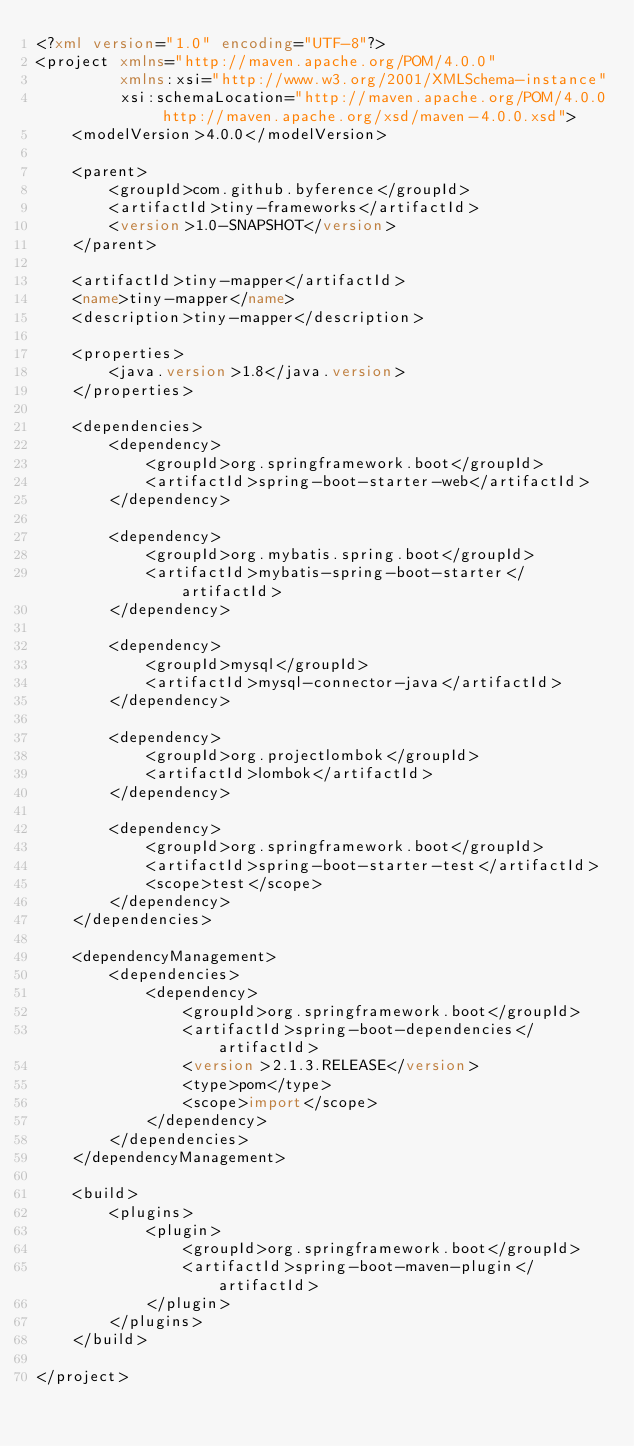Convert code to text. <code><loc_0><loc_0><loc_500><loc_500><_XML_><?xml version="1.0" encoding="UTF-8"?>
<project xmlns="http://maven.apache.org/POM/4.0.0"
         xmlns:xsi="http://www.w3.org/2001/XMLSchema-instance"
         xsi:schemaLocation="http://maven.apache.org/POM/4.0.0 http://maven.apache.org/xsd/maven-4.0.0.xsd">
    <modelVersion>4.0.0</modelVersion>

    <parent>
        <groupId>com.github.byference</groupId>
        <artifactId>tiny-frameworks</artifactId>
        <version>1.0-SNAPSHOT</version>
    </parent>

    <artifactId>tiny-mapper</artifactId>
    <name>tiny-mapper</name>
    <description>tiny-mapper</description>

    <properties>
        <java.version>1.8</java.version>
    </properties>

    <dependencies>
        <dependency>
            <groupId>org.springframework.boot</groupId>
            <artifactId>spring-boot-starter-web</artifactId>
        </dependency>

        <dependency>
            <groupId>org.mybatis.spring.boot</groupId>
            <artifactId>mybatis-spring-boot-starter</artifactId>
        </dependency>

        <dependency>
            <groupId>mysql</groupId>
            <artifactId>mysql-connector-java</artifactId>
        </dependency>

        <dependency>
            <groupId>org.projectlombok</groupId>
            <artifactId>lombok</artifactId>
        </dependency>

        <dependency>
            <groupId>org.springframework.boot</groupId>
            <artifactId>spring-boot-starter-test</artifactId>
            <scope>test</scope>
        </dependency>
    </dependencies>

    <dependencyManagement>
        <dependencies>
            <dependency>
                <groupId>org.springframework.boot</groupId>
                <artifactId>spring-boot-dependencies</artifactId>
                <version>2.1.3.RELEASE</version>
                <type>pom</type>
                <scope>import</scope>
            </dependency>
        </dependencies>
    </dependencyManagement>

    <build>
        <plugins>
            <plugin>
                <groupId>org.springframework.boot</groupId>
                <artifactId>spring-boot-maven-plugin</artifactId>
            </plugin>
        </plugins>
    </build>

</project></code> 